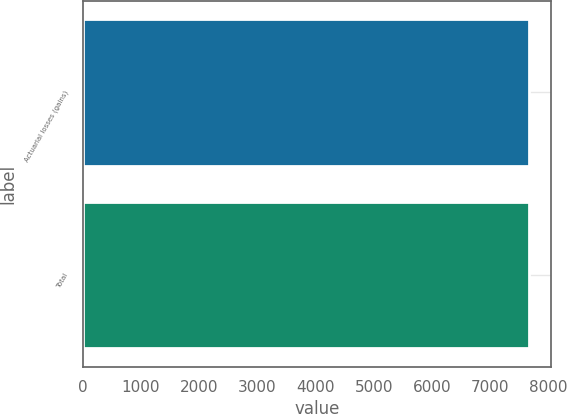<chart> <loc_0><loc_0><loc_500><loc_500><bar_chart><fcel>Actuarial losses (gains)<fcel>Total<nl><fcel>7664<fcel>7664.1<nl></chart> 